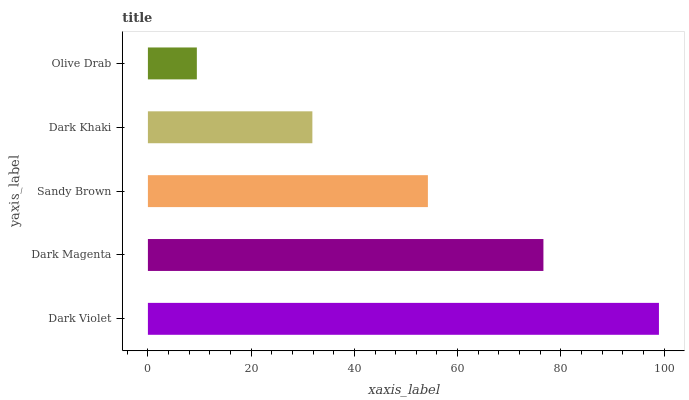Is Olive Drab the minimum?
Answer yes or no. Yes. Is Dark Violet the maximum?
Answer yes or no. Yes. Is Dark Magenta the minimum?
Answer yes or no. No. Is Dark Magenta the maximum?
Answer yes or no. No. Is Dark Violet greater than Dark Magenta?
Answer yes or no. Yes. Is Dark Magenta less than Dark Violet?
Answer yes or no. Yes. Is Dark Magenta greater than Dark Violet?
Answer yes or no. No. Is Dark Violet less than Dark Magenta?
Answer yes or no. No. Is Sandy Brown the high median?
Answer yes or no. Yes. Is Sandy Brown the low median?
Answer yes or no. Yes. Is Dark Khaki the high median?
Answer yes or no. No. Is Dark Magenta the low median?
Answer yes or no. No. 